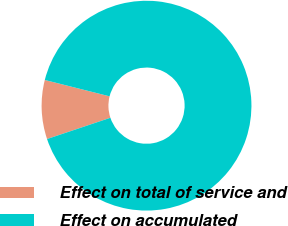Convert chart to OTSL. <chart><loc_0><loc_0><loc_500><loc_500><pie_chart><fcel>Effect on total of service and<fcel>Effect on accumulated<nl><fcel>9.09%<fcel>90.91%<nl></chart> 